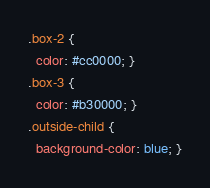Convert code to text. <code><loc_0><loc_0><loc_500><loc_500><_CSS_>.box-2 {
  color: #cc0000; }
.box-3 {
  color: #b30000; }
.outside-child {
  background-color: blue; }
</code> 